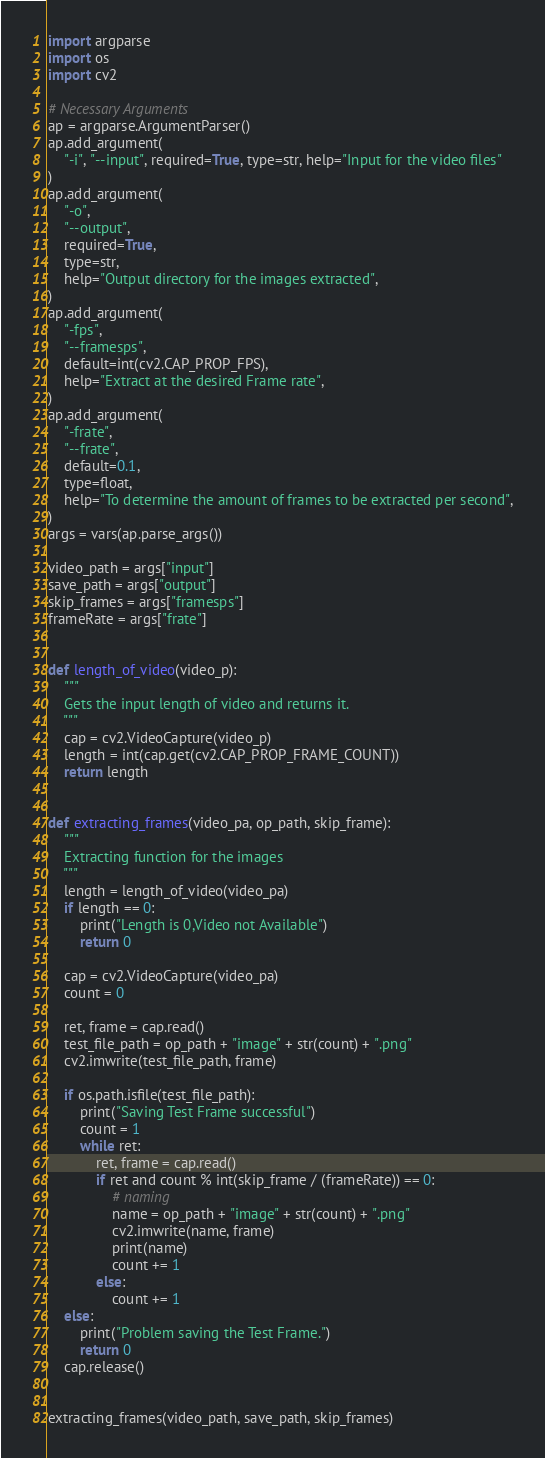<code> <loc_0><loc_0><loc_500><loc_500><_Python_>import argparse
import os
import cv2

# Necessary Arguments
ap = argparse.ArgumentParser()
ap.add_argument(
    "-i", "--input", required=True, type=str, help="Input for the video files"
)
ap.add_argument(
    "-o",
    "--output",
    required=True,
    type=str,
    help="Output directory for the images extracted",
)
ap.add_argument(
    "-fps",
    "--framesps",
    default=int(cv2.CAP_PROP_FPS),
    help="Extract at the desired Frame rate",
)
ap.add_argument(
    "-frate",
    "--frate",
    default=0.1,
    type=float,
    help="To determine the amount of frames to be extracted per second",
)
args = vars(ap.parse_args())

video_path = args["input"]
save_path = args["output"]
skip_frames = args["framesps"]
frameRate = args["frate"]


def length_of_video(video_p):
    """
    Gets the input length of video and returns it.
    """
    cap = cv2.VideoCapture(video_p)
    length = int(cap.get(cv2.CAP_PROP_FRAME_COUNT))
    return length


def extracting_frames(video_pa, op_path, skip_frame):
    """
    Extracting function for the images
    """
    length = length_of_video(video_pa)
    if length == 0:
        print("Length is 0,Video not Available")
        return 0

    cap = cv2.VideoCapture(video_pa)
    count = 0

    ret, frame = cap.read()
    test_file_path = op_path + "image" + str(count) + ".png"
    cv2.imwrite(test_file_path, frame)

    if os.path.isfile(test_file_path):
        print("Saving Test Frame successful")
        count = 1
        while ret:
            ret, frame = cap.read()
            if ret and count % int(skip_frame / (frameRate)) == 0:
                # naming
                name = op_path + "image" + str(count) + ".png"
                cv2.imwrite(name, frame)
                print(name)
                count += 1
            else:
                count += 1
    else:
        print("Problem saving the Test Frame.")
        return 0
    cap.release()


extracting_frames(video_path, save_path, skip_frames)
</code> 